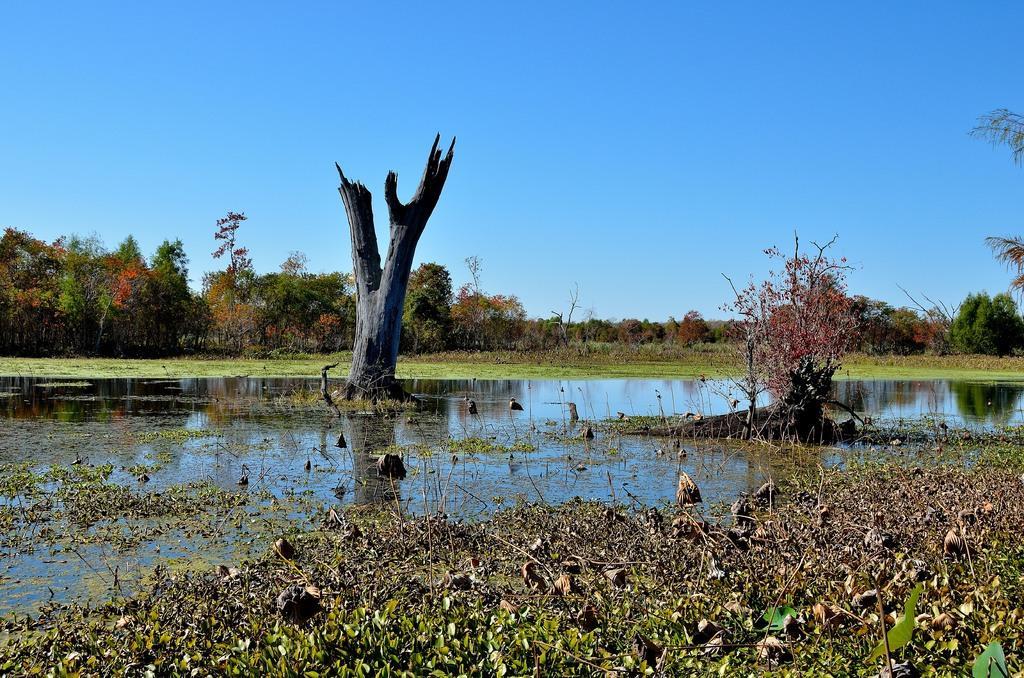In one or two sentences, can you explain what this image depicts? In this picture we can see water. On the bottom we can see grass. On the background we can see many trees. On the top there is a sky. 